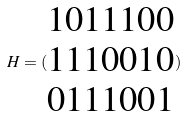<formula> <loc_0><loc_0><loc_500><loc_500>H = ( \begin{matrix} 1 0 1 1 1 0 0 \\ 1 1 1 0 0 1 0 \\ 0 1 1 1 0 0 1 \end{matrix} )</formula> 